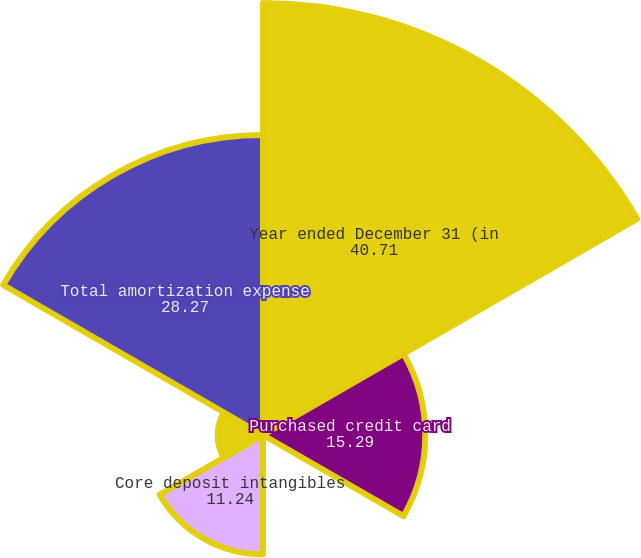Convert chart to OTSL. <chart><loc_0><loc_0><loc_500><loc_500><pie_chart><fcel>Year ended December 31 (in<fcel>Purchased credit card<fcel>Other credit card-related<fcel>Core deposit intangibles<fcel>Other intangibles (a)<fcel>Total amortization expense<nl><fcel>40.71%<fcel>15.29%<fcel>0.22%<fcel>11.24%<fcel>4.27%<fcel>28.27%<nl></chart> 